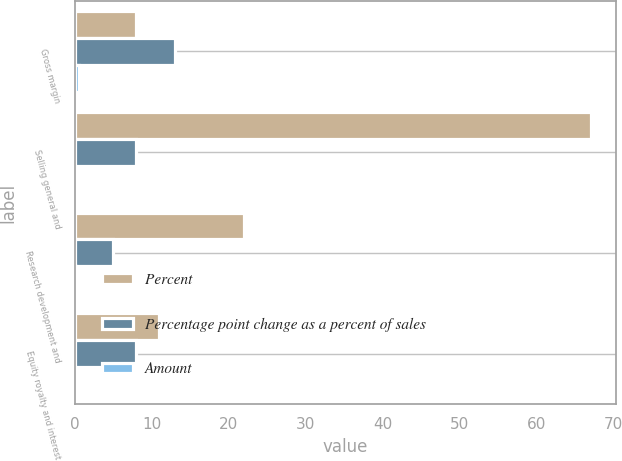Convert chart to OTSL. <chart><loc_0><loc_0><loc_500><loc_500><stacked_bar_chart><ecel><fcel>Gross margin<fcel>Selling general and<fcel>Research development and<fcel>Equity royalty and interest<nl><fcel>Percent<fcel>8<fcel>67<fcel>22<fcel>11<nl><fcel>Percentage point change as a percent of sales<fcel>13<fcel>8<fcel>5<fcel>8<nl><fcel>Amount<fcel>0.6<fcel>0.1<fcel>0.2<fcel>0.1<nl></chart> 